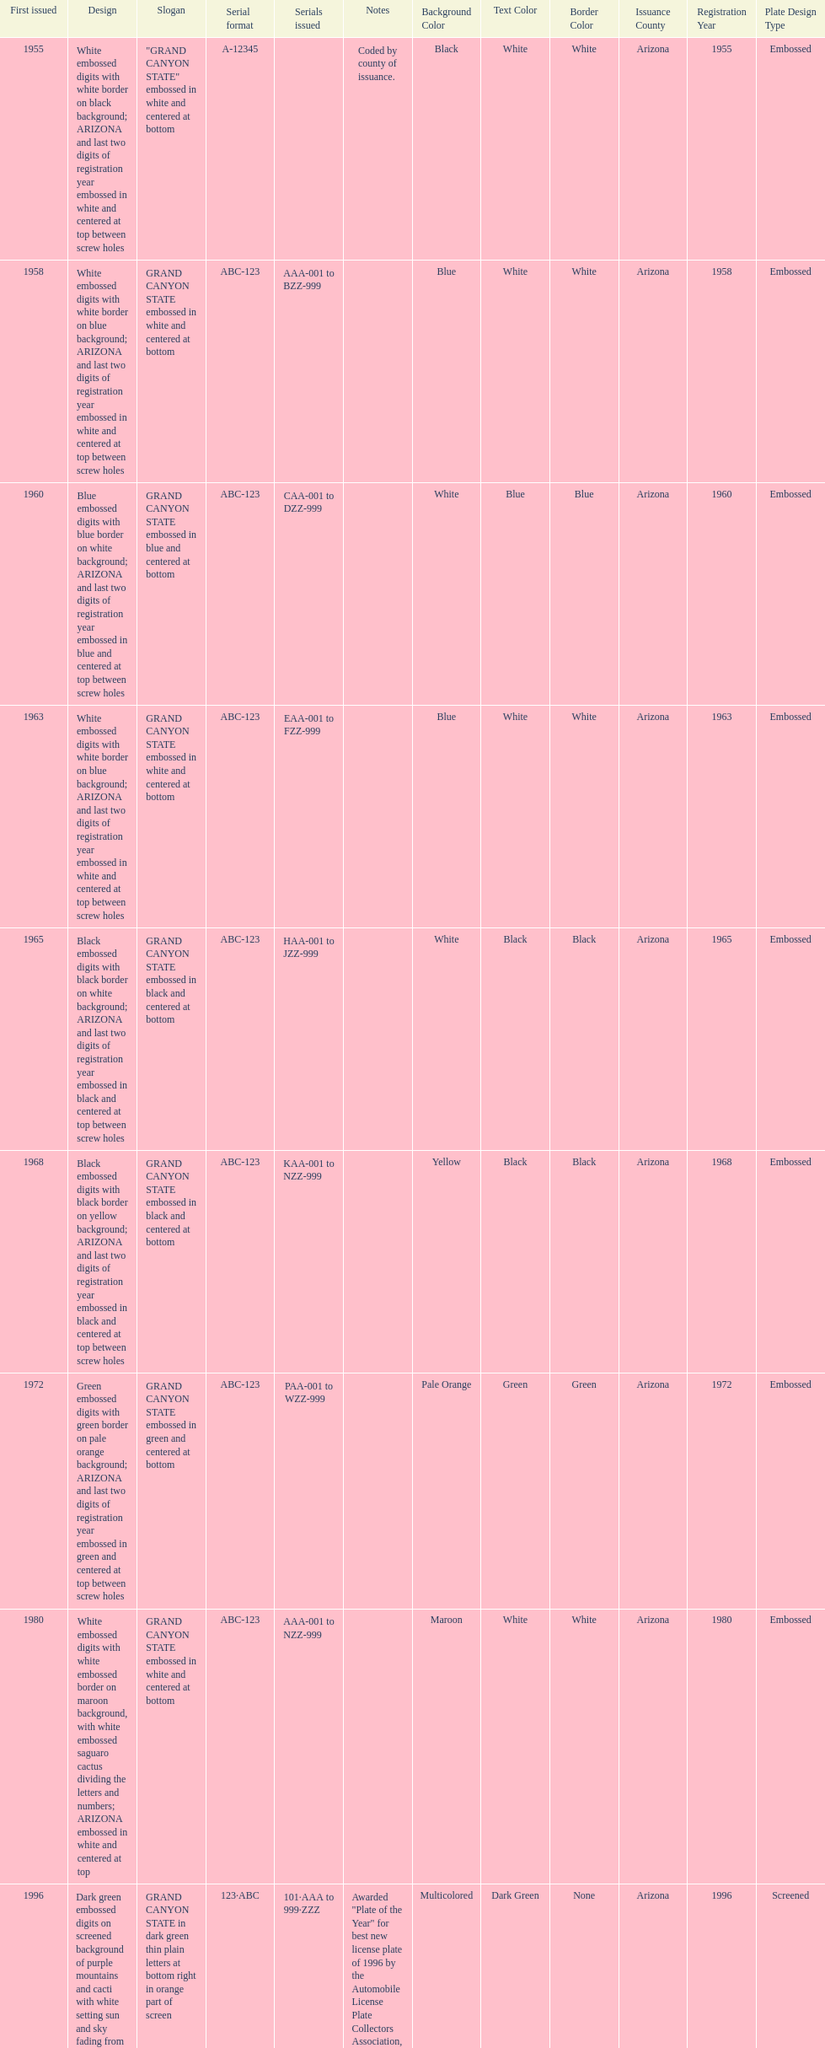What was year was the first arizona license plate made? 1955. 